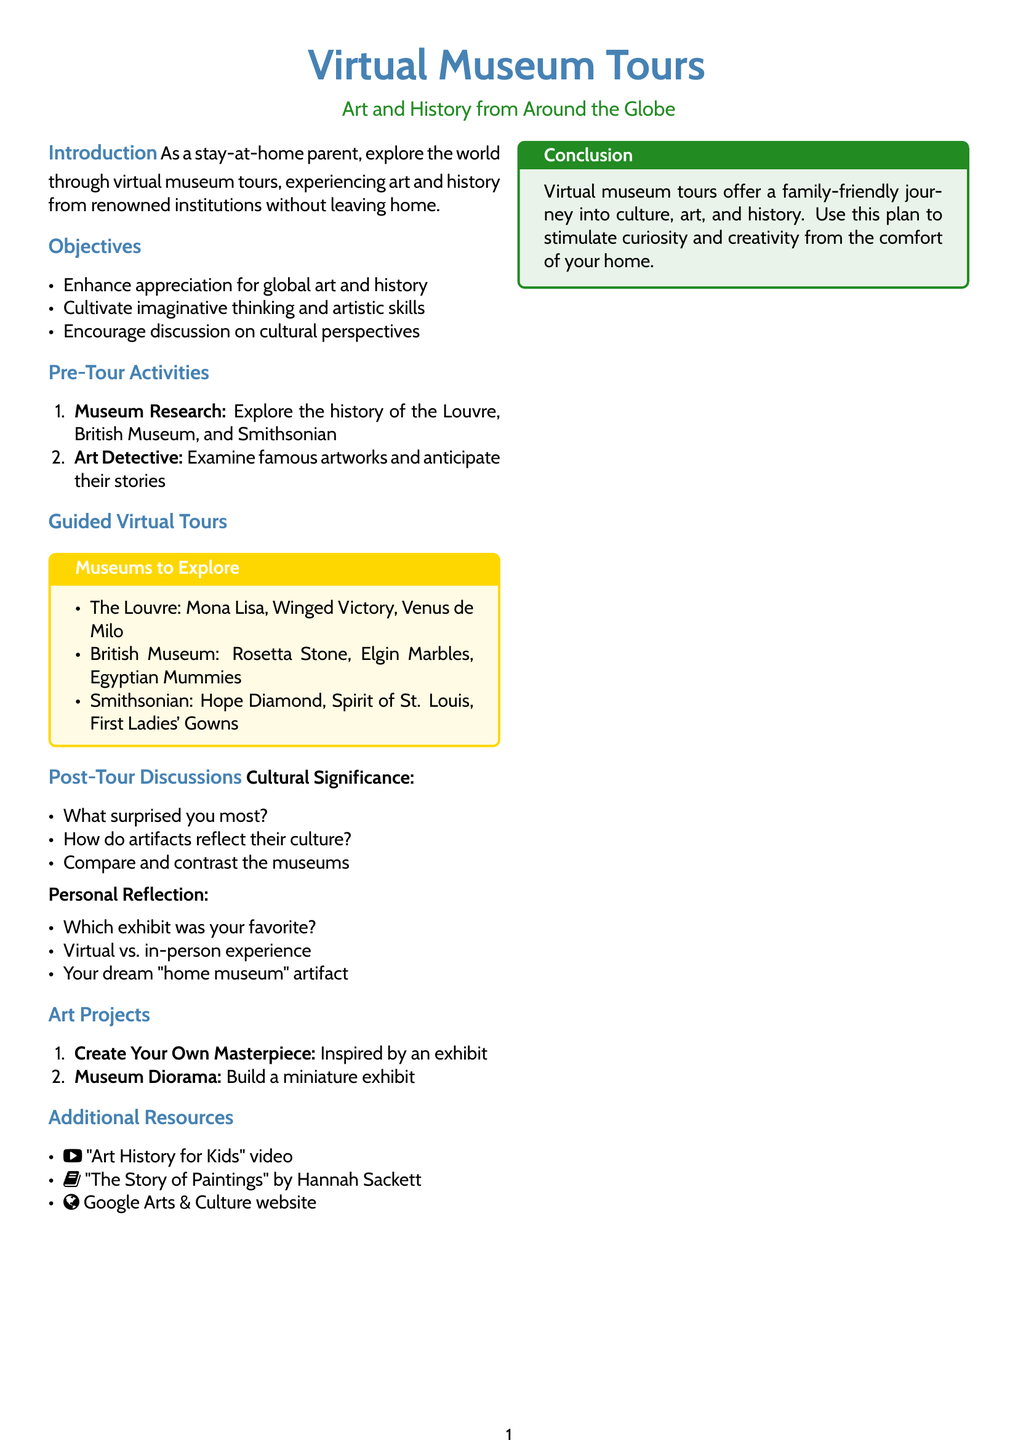What are the objectives of the lesson? The objectives of the lesson are listed in the document and include enhancing appreciation for global art and history, cultivating imaginative thinking and artistic skills, and encouraging discussion on cultural perspectives.
Answer: Enhance appreciation for global art and history, cultivate imaginative thinking and artistic skills, encourage discussion on cultural perspectives Which three museums are featured in the guided virtual tours? The document lists specific museums to explore during the virtual tours, which include the Louvre, British Museum, and Smithsonian.
Answer: The Louvre, British Museum, Smithsonian What is the name of the book recommended in additional resources? The document provides a recommendation for additional reading, which is titled "The Story of Paintings" by Hannah Sackett.
Answer: The Story of Paintings What type of projects are included after the tours? The lesson plan specifies types of art projects that can be done after the tours, which focus on creating art inspired by museum exhibits.
Answer: Create Your Own Masterpiece, Museum Diorama What is a post-tour discussion question related to cultural significance? The document lists several questions for post-tour discussions, and one asks how artifacts reflect their culture.
Answer: How do artifacts reflect their culture? Which exhibit features the Mona Lisa? The guided virtual tours include this specific exhibit at the Louvre, which is famous for housing the Mona Lisa.
Answer: The Louvre 